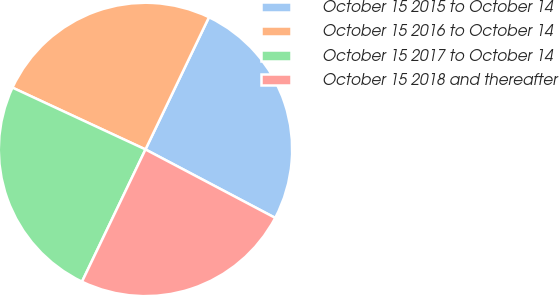Convert chart. <chart><loc_0><loc_0><loc_500><loc_500><pie_chart><fcel>October 15 2015 to October 14<fcel>October 15 2016 to October 14<fcel>October 15 2017 to October 14<fcel>October 15 2018 and thereafter<nl><fcel>25.6%<fcel>25.2%<fcel>24.8%<fcel>24.4%<nl></chart> 